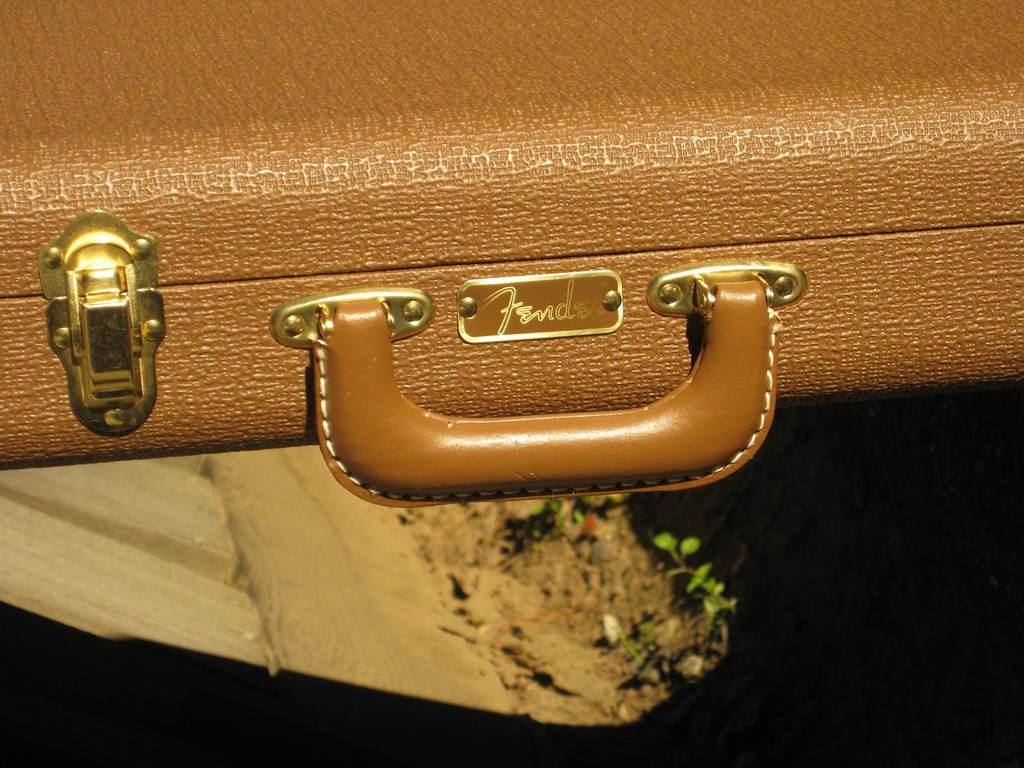What object can be seen in the image? There is a suitcase in the image. What is the color of the suitcase? The suitcase is brown in color. What feature does the suitcase have for carrying or moving it? The suitcase has a handle. What type of insect can be seen crawling on the suitcase in the image? There are no insects present on the suitcase in the image. 